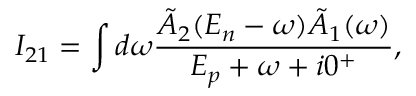Convert formula to latex. <formula><loc_0><loc_0><loc_500><loc_500>I _ { 2 1 } = \int d \omega \frac { \tilde { A } _ { 2 } ( E _ { n } - \omega ) \tilde { A } _ { 1 } ( \omega ) } { E _ { p } + \omega + i 0 ^ { + } } ,</formula> 